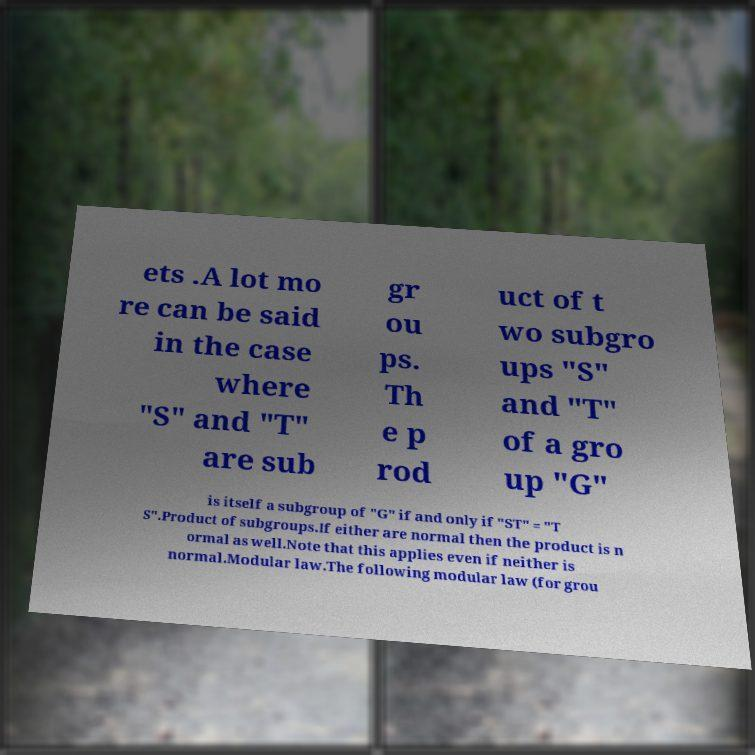Please identify and transcribe the text found in this image. ets .A lot mo re can be said in the case where "S" and "T" are sub gr ou ps. Th e p rod uct of t wo subgro ups "S" and "T" of a gro up "G" is itself a subgroup of "G" if and only if "ST" = "T S".Product of subgroups.If either are normal then the product is n ormal as well.Note that this applies even if neither is normal.Modular law.The following modular law (for grou 